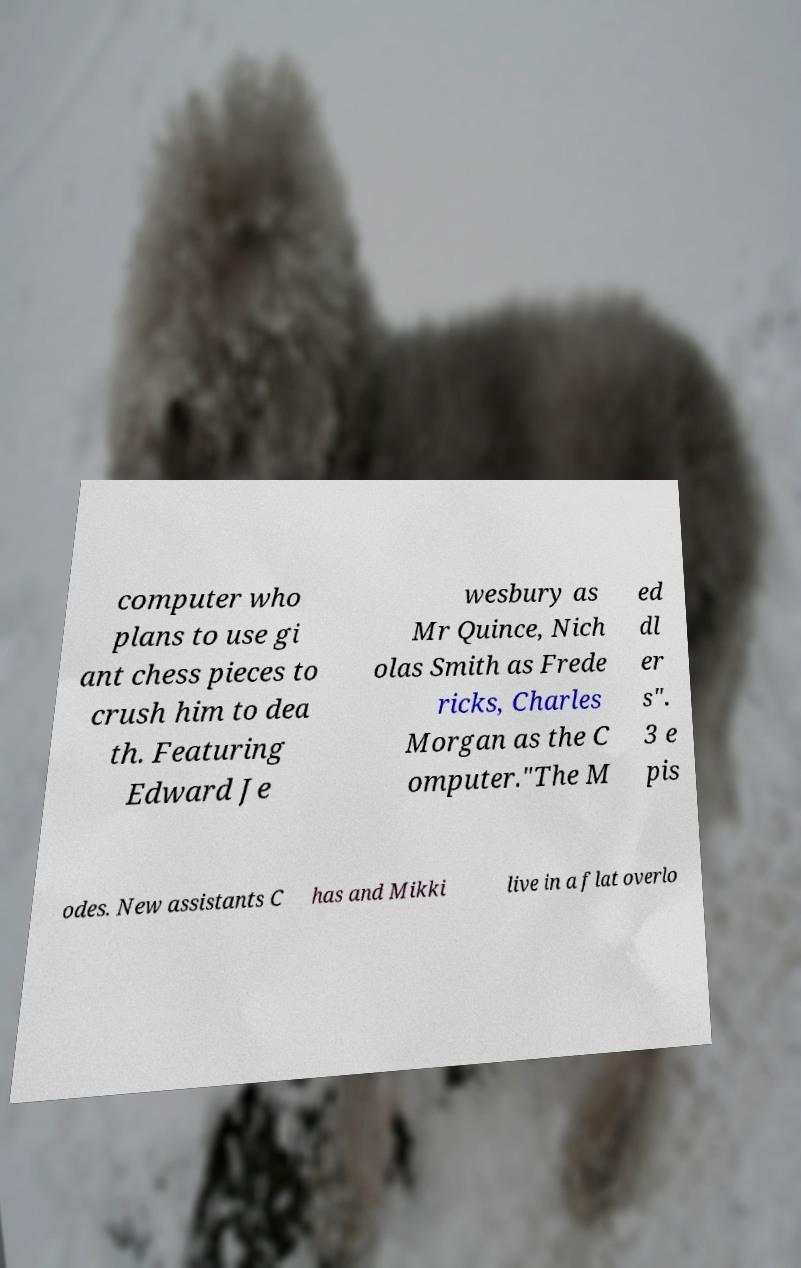Could you assist in decoding the text presented in this image and type it out clearly? computer who plans to use gi ant chess pieces to crush him to dea th. Featuring Edward Je wesbury as Mr Quince, Nich olas Smith as Frede ricks, Charles Morgan as the C omputer."The M ed dl er s". 3 e pis odes. New assistants C has and Mikki live in a flat overlo 